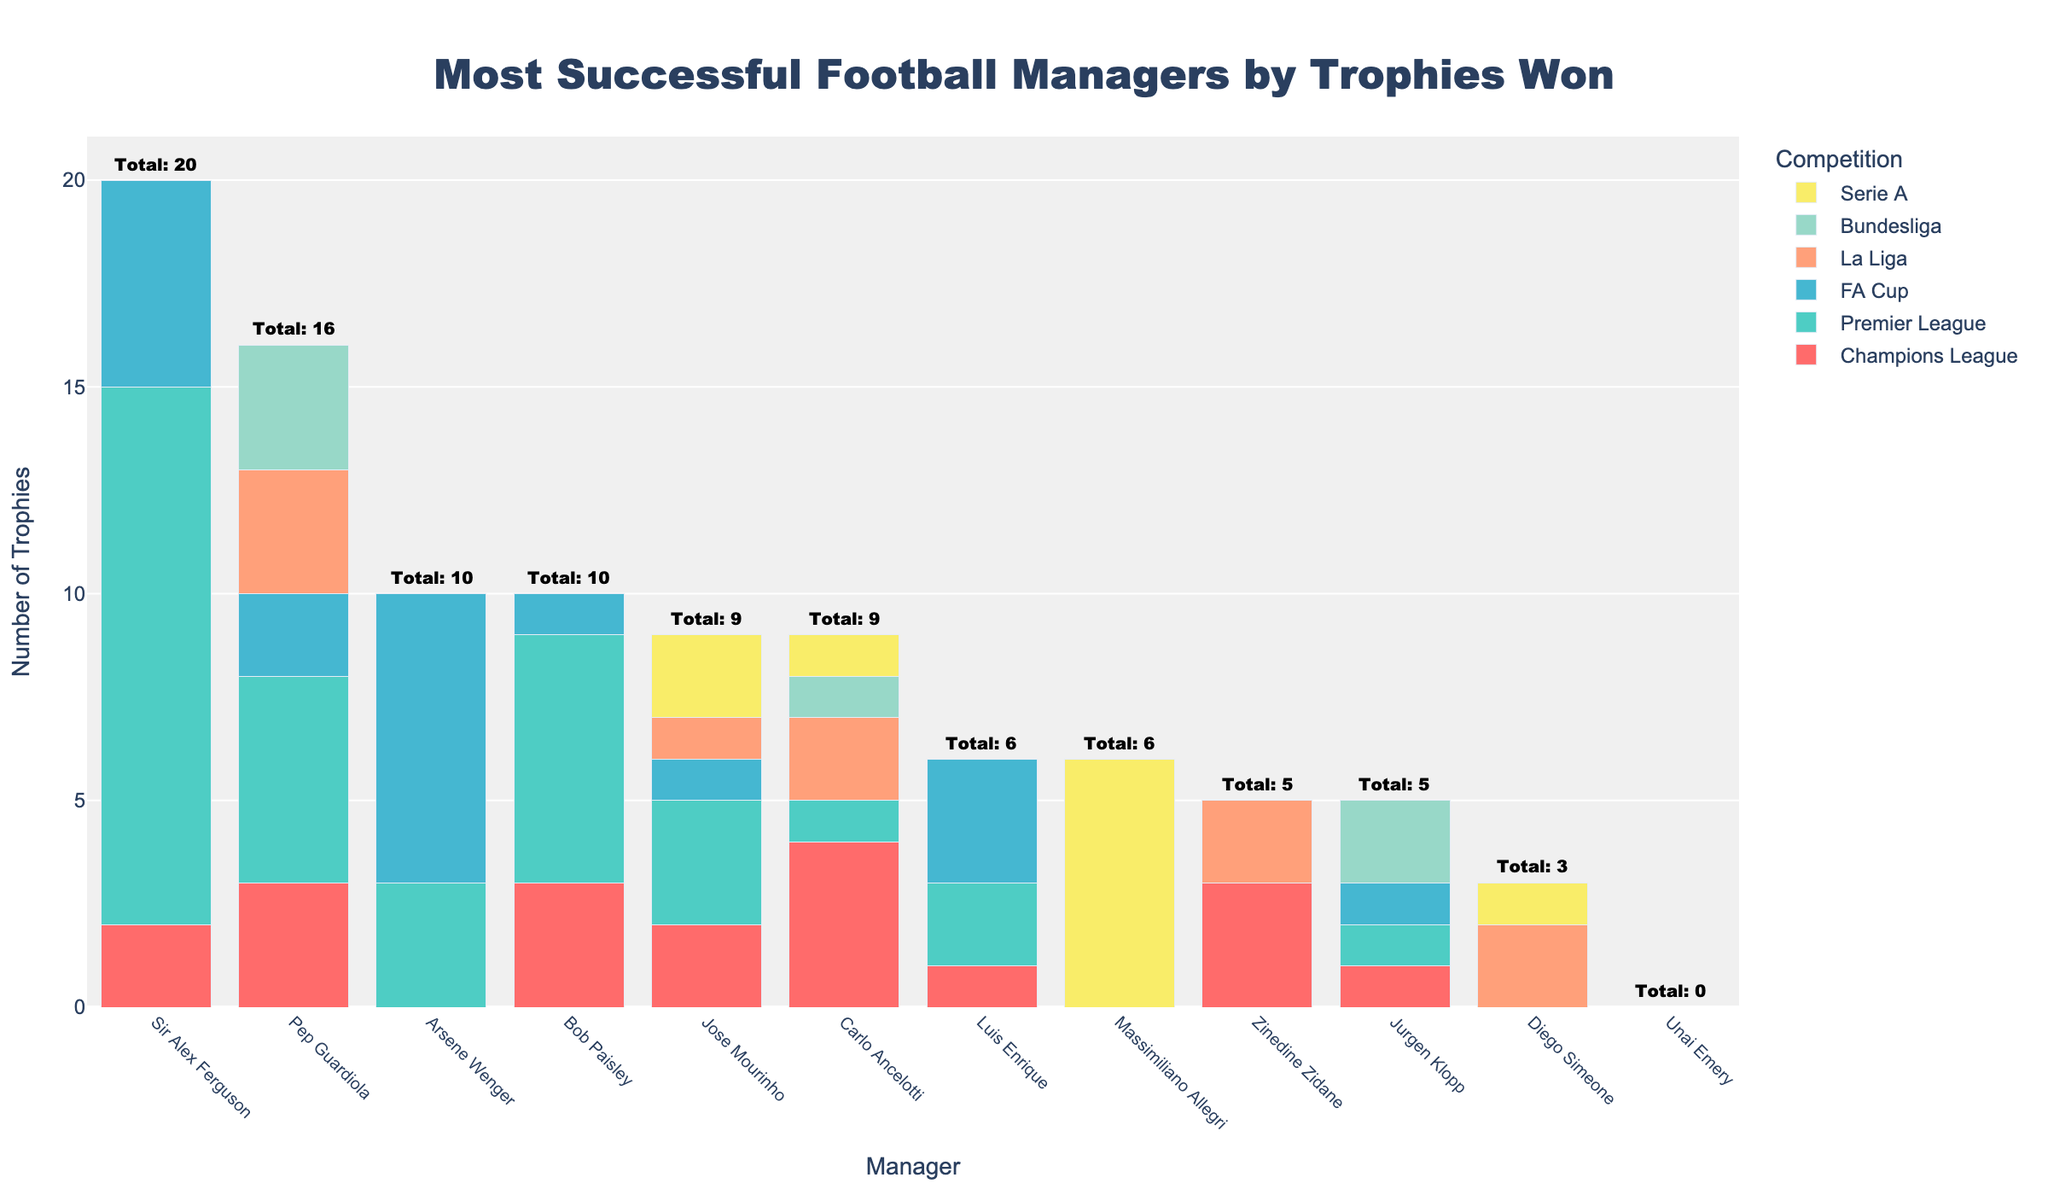Who is the most successful manager in terms of total trophies won? To determine the most successful manager, sum the trophies from all competitions for each manager and find the manager with the highest total. According to the annotations, Sir Alex Ferguson has the highest total trophies.
Answer: Sir Alex Ferguson How many Champions League trophies did Carlo Ancelotti win compared to Zinedine Zidane? Look at the heights of the bars corresponding to the Champions League for both managers. Ancelotti has 4 while Zidane has 3.
Answer: Ancelotti: 4, Zidane: 3 Which manager has the highest number of Premier League trophies? Check the heights of the bars corresponding to the Premier League for each manager. Sir Alex Ferguson has the highest with 13 trophies.
Answer: Sir Alex Ferguson How many total trophies have managers won in Serie A? Add up the trophies from the Serie A category for all managers. Massimiliano Allegri has 6, Jose Mourinho and Carlo Ancelotti each have 1, and Diego Simeone has 1. Therefore, the total is 6 + 1 + 1 + 1 = 9.
Answer: 9 Which manager has not won any trophies in any of the competitions listed? Look for a manager with bars of zero height in all categories. Unai Emery has zero in each competition.
Answer: Unai Emery Who has won more trophies in La Liga, Pep Guardiola or Diego Simeone? Compare the heights of the La Liga bars for both managers. Pep Guardiola has 3, while Diego Simeone has 2.
Answer: Pep Guardiola What is the total number of FA Cups won by Arsene Wenger and Sir Alex Ferguson combined? Add the bars for Arsene Wenger and Sir Alex Ferguson in the FA Cup category. Wenger has 7 and Ferguson has 5. Therefore, the total is 7 + 5 = 12.
Answer: 12 Which competition did Jurgen Klopp win his highest number of trophies in? Compare the heights of all the bars for Jurgen Klopp. His highest bar is for the Bundesliga, where he won 2 trophies.
Answer: Bundesliga How many managers have won at least one trophy in the Premier League? Count the number of managers with a bar height greater than zero in the Premier League category. There are 5 managers: Sir Alex Ferguson, Pep Guardiola, Jose Mourinho, Jurgen Klopp, and Arsene Wenger.
Answer: 5 Did any manager win an equal number of trophies in the Premier League and Champions League? Compare the bars for the Premier League and Champions League for each manager. Both Jose Mourinho and Jurgen Klopp have the same number (2 in the Champions League and 3 in the Premier League for Mourinho; 1 each in both for Klopp).
Answer: Yes, Jose Mourinho and Jurgen Klopp 